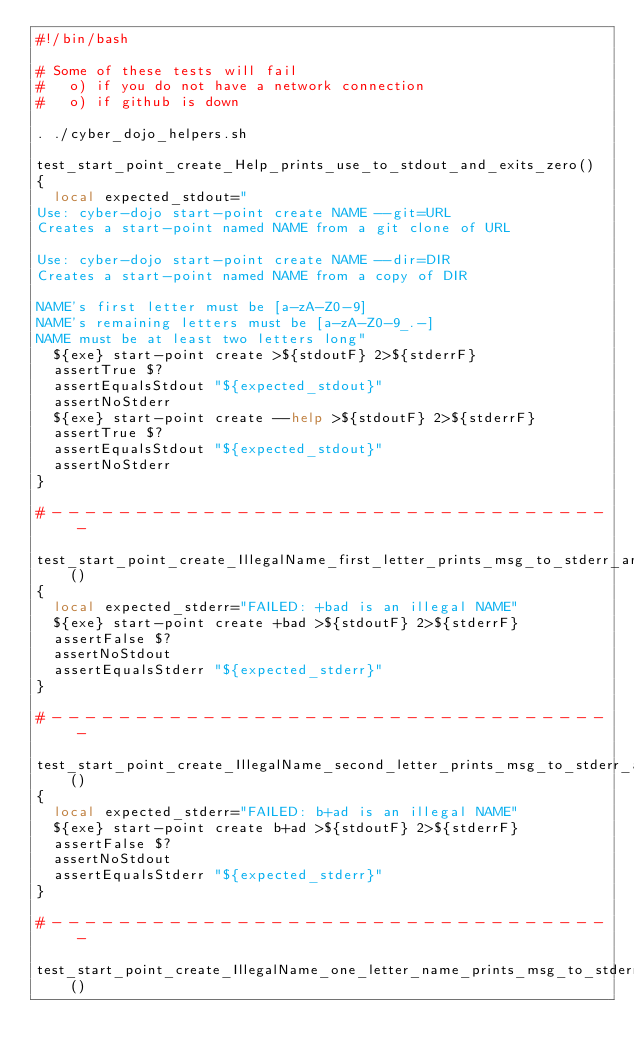<code> <loc_0><loc_0><loc_500><loc_500><_Bash_>#!/bin/bash

# Some of these tests will fail
#   o) if you do not have a network connection
#   o) if github is down

. ./cyber_dojo_helpers.sh

test_start_point_create_Help_prints_use_to_stdout_and_exits_zero()
{
  local expected_stdout="
Use: cyber-dojo start-point create NAME --git=URL
Creates a start-point named NAME from a git clone of URL

Use: cyber-dojo start-point create NAME --dir=DIR
Creates a start-point named NAME from a copy of DIR

NAME's first letter must be [a-zA-Z0-9]
NAME's remaining letters must be [a-zA-Z0-9_.-]
NAME must be at least two letters long"
  ${exe} start-point create >${stdoutF} 2>${stderrF}
  assertTrue $?
  assertEqualsStdout "${expected_stdout}"
  assertNoStderr
  ${exe} start-point create --help >${stdoutF} 2>${stderrF}
  assertTrue $?
  assertEqualsStdout "${expected_stdout}"
  assertNoStderr
}

# - - - - - - - - - - - - - - - - - - - - - - - - - - - - - - - - - -

test_start_point_create_IllegalName_first_letter_prints_msg_to_stderr_and_exits_non_zero()
{
  local expected_stderr="FAILED: +bad is an illegal NAME"
  ${exe} start-point create +bad >${stdoutF} 2>${stderrF}
  assertFalse $?
  assertNoStdout
  assertEqualsStderr "${expected_stderr}"
}

# - - - - - - - - - - - - - - - - - - - - - - - - - - - - - - - - - -

test_start_point_create_IllegalName_second_letter_prints_msg_to_stderr_and_exits_non_zero()
{
  local expected_stderr="FAILED: b+ad is an illegal NAME"
  ${exe} start-point create b+ad >${stdoutF} 2>${stderrF}
  assertFalse $?
  assertNoStdout
  assertEqualsStderr "${expected_stderr}"
}

# - - - - - - - - - - - - - - - - - - - - - - - - - - - - - - - - - -

test_start_point_create_IllegalName_one_letter_name_prints_msg_to_stderr_and_exits_non_zero()</code> 